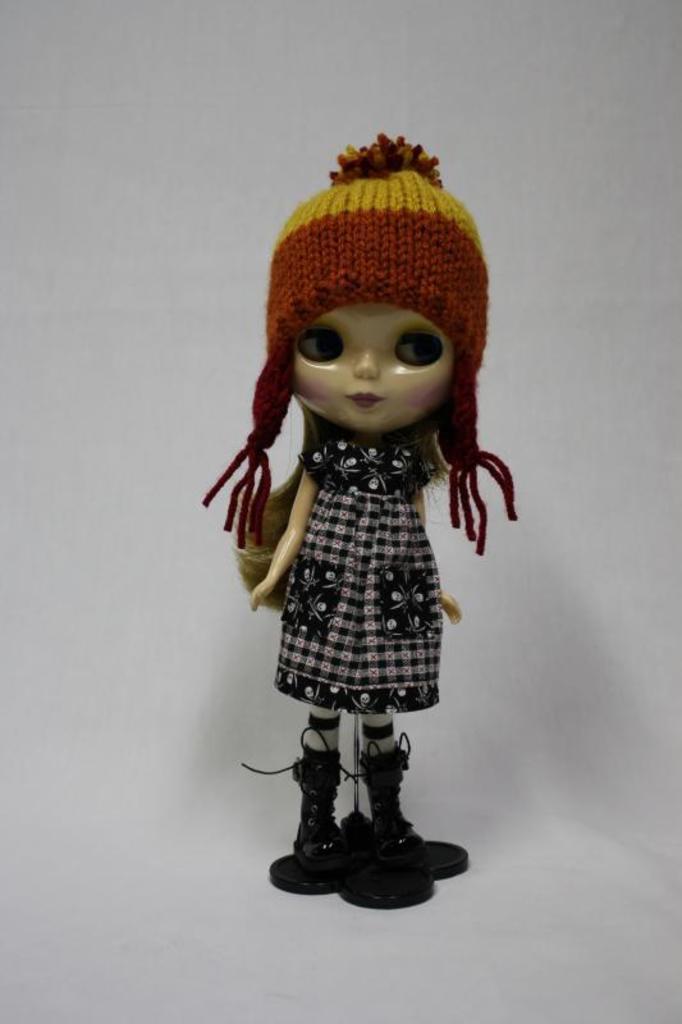Could you give a brief overview of what you see in this image? In this image we can see a doll. There is a white background in the image. 